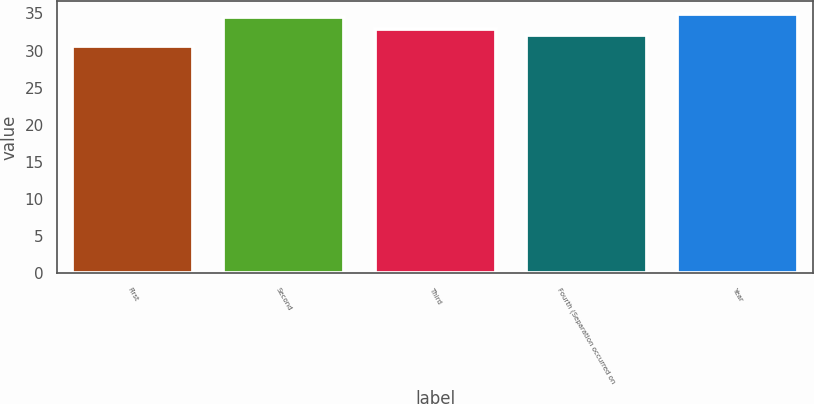Convert chart to OTSL. <chart><loc_0><loc_0><loc_500><loc_500><bar_chart><fcel>First<fcel>Second<fcel>Third<fcel>Fourth (Separation occurred on<fcel>Year<nl><fcel>30.66<fcel>34.5<fcel>32.91<fcel>32.1<fcel>34.88<nl></chart> 